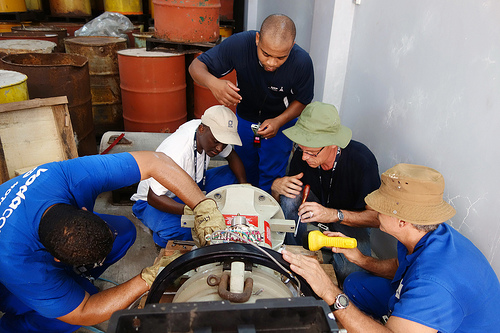<image>
Is the barrel behind the hat? No. The barrel is not behind the hat. From this viewpoint, the barrel appears to be positioned elsewhere in the scene. 